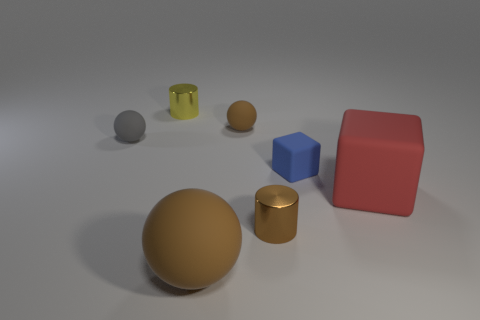Subtract all blue blocks. Subtract all red spheres. How many blocks are left? 1 Add 2 brown rubber things. How many objects exist? 9 Subtract all spheres. How many objects are left? 4 Subtract all tiny blue cylinders. Subtract all matte cubes. How many objects are left? 5 Add 3 metallic things. How many metallic things are left? 5 Add 2 big red blocks. How many big red blocks exist? 3 Subtract 0 cyan cylinders. How many objects are left? 7 